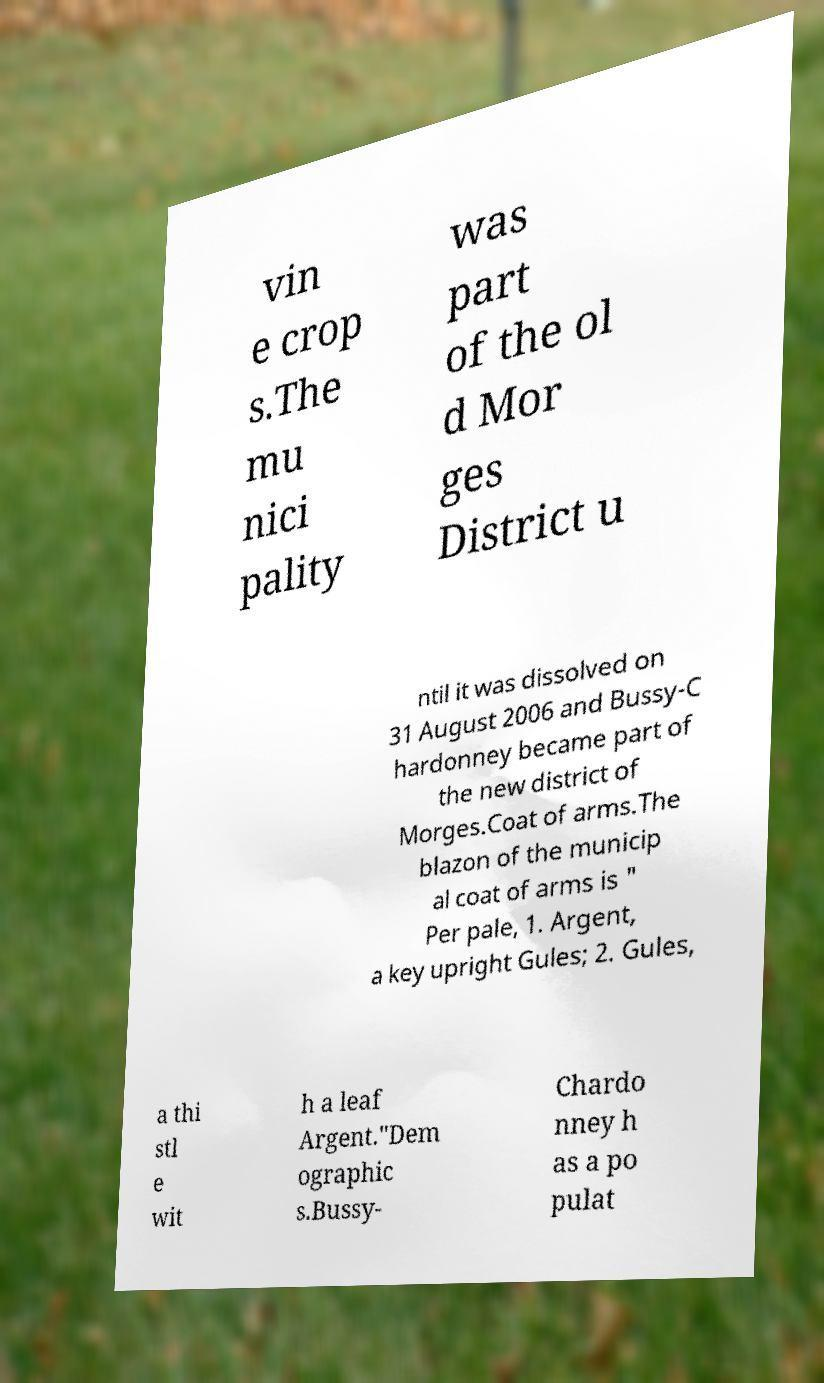Please read and relay the text visible in this image. What does it say? vin e crop s.The mu nici pality was part of the ol d Mor ges District u ntil it was dissolved on 31 August 2006 and Bussy-C hardonney became part of the new district of Morges.Coat of arms.The blazon of the municip al coat of arms is " Per pale, 1. Argent, a key upright Gules; 2. Gules, a thi stl e wit h a leaf Argent."Dem ographic s.Bussy- Chardo nney h as a po pulat 